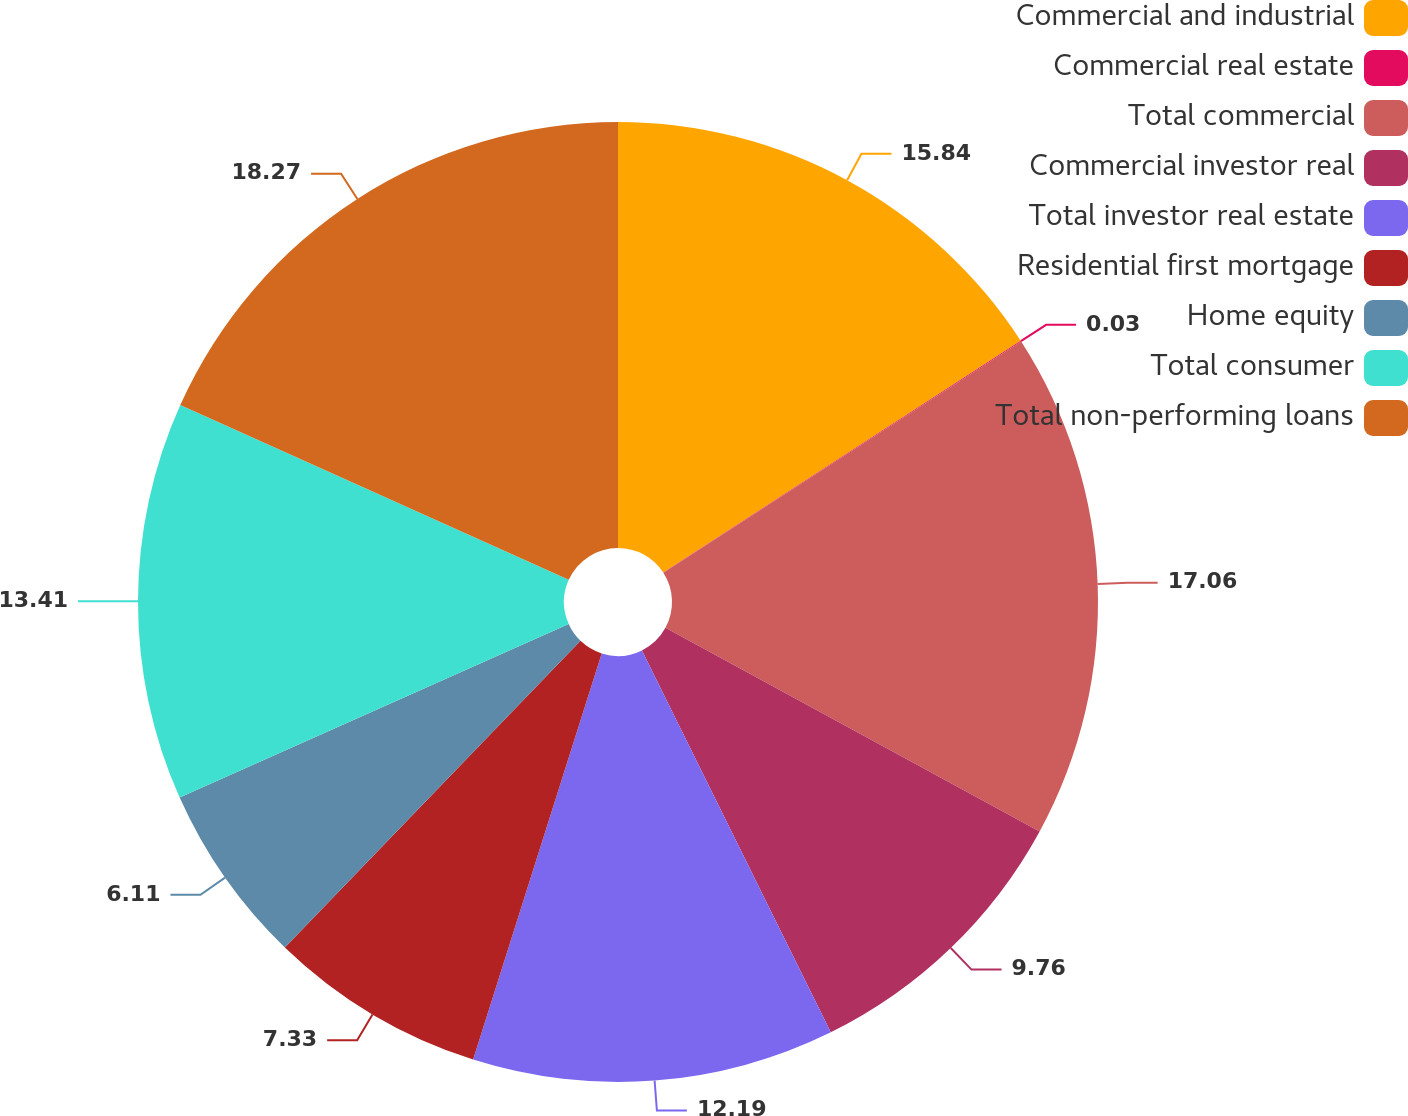Convert chart to OTSL. <chart><loc_0><loc_0><loc_500><loc_500><pie_chart><fcel>Commercial and industrial<fcel>Commercial real estate<fcel>Total commercial<fcel>Commercial investor real<fcel>Total investor real estate<fcel>Residential first mortgage<fcel>Home equity<fcel>Total consumer<fcel>Total non-performing loans<nl><fcel>15.84%<fcel>0.03%<fcel>17.06%<fcel>9.76%<fcel>12.19%<fcel>7.33%<fcel>6.11%<fcel>13.41%<fcel>18.27%<nl></chart> 